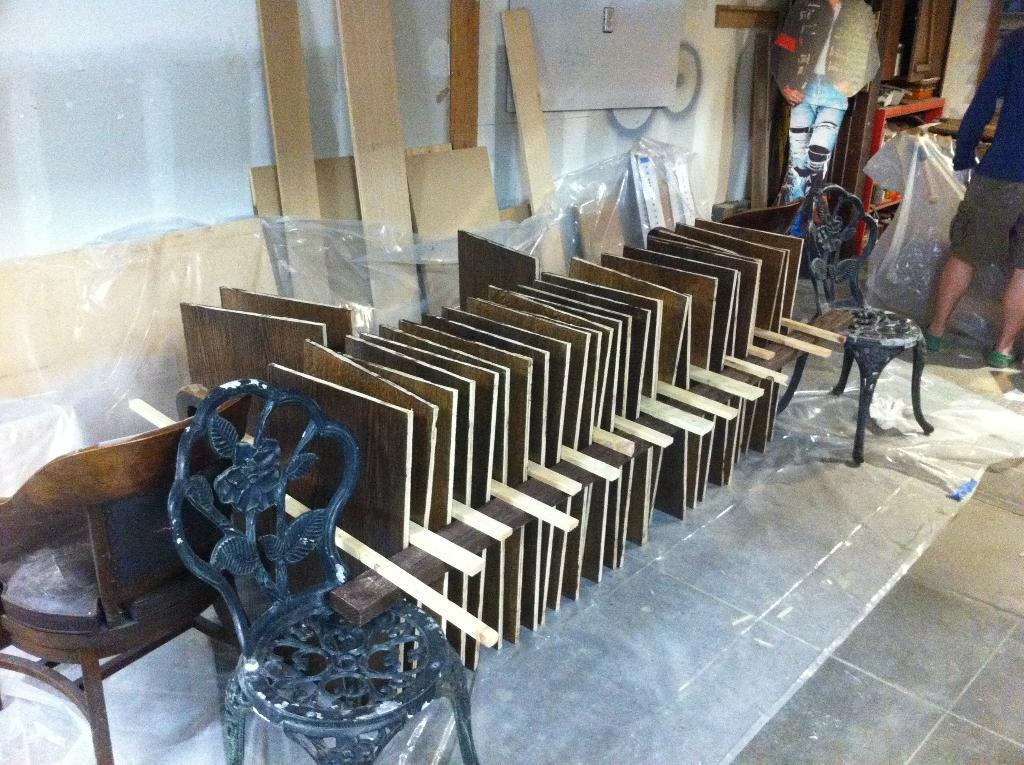In one or two sentences, can you explain what this image depicts? In this picture we can see wooden cardboard pieces arranged in a sequence manner on the floor. Here we can see wooden pieces. Here we can see a man standing on the floor. 